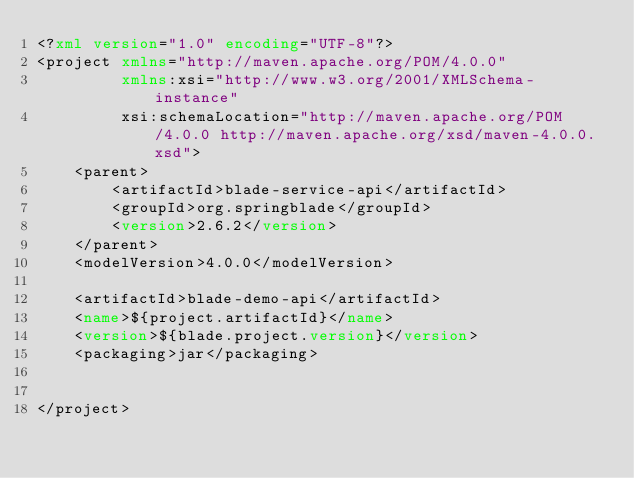<code> <loc_0><loc_0><loc_500><loc_500><_XML_><?xml version="1.0" encoding="UTF-8"?>
<project xmlns="http://maven.apache.org/POM/4.0.0"
         xmlns:xsi="http://www.w3.org/2001/XMLSchema-instance"
         xsi:schemaLocation="http://maven.apache.org/POM/4.0.0 http://maven.apache.org/xsd/maven-4.0.0.xsd">
    <parent>
        <artifactId>blade-service-api</artifactId>
        <groupId>org.springblade</groupId>
        <version>2.6.2</version>
    </parent>
    <modelVersion>4.0.0</modelVersion>

    <artifactId>blade-demo-api</artifactId>
    <name>${project.artifactId}</name>
    <version>${blade.project.version}</version>
    <packaging>jar</packaging>


</project>
</code> 